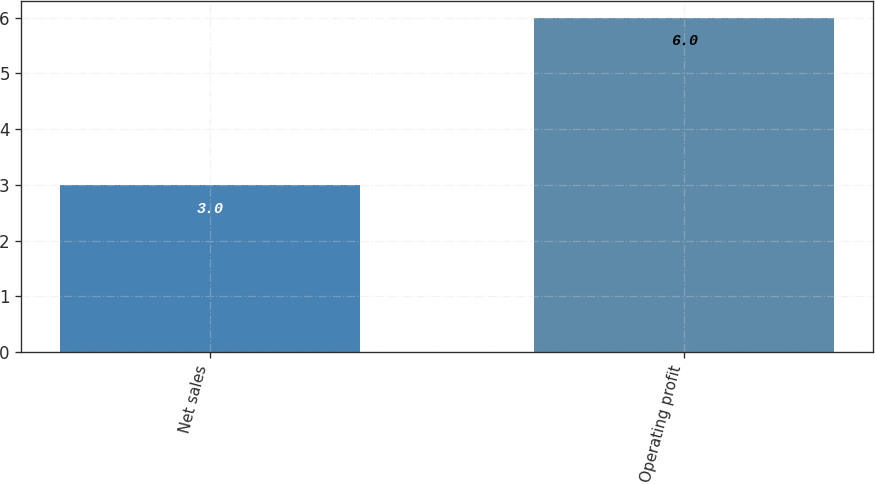Convert chart to OTSL. <chart><loc_0><loc_0><loc_500><loc_500><bar_chart><fcel>Net sales<fcel>Operating profit<nl><fcel>3<fcel>6<nl></chart> 